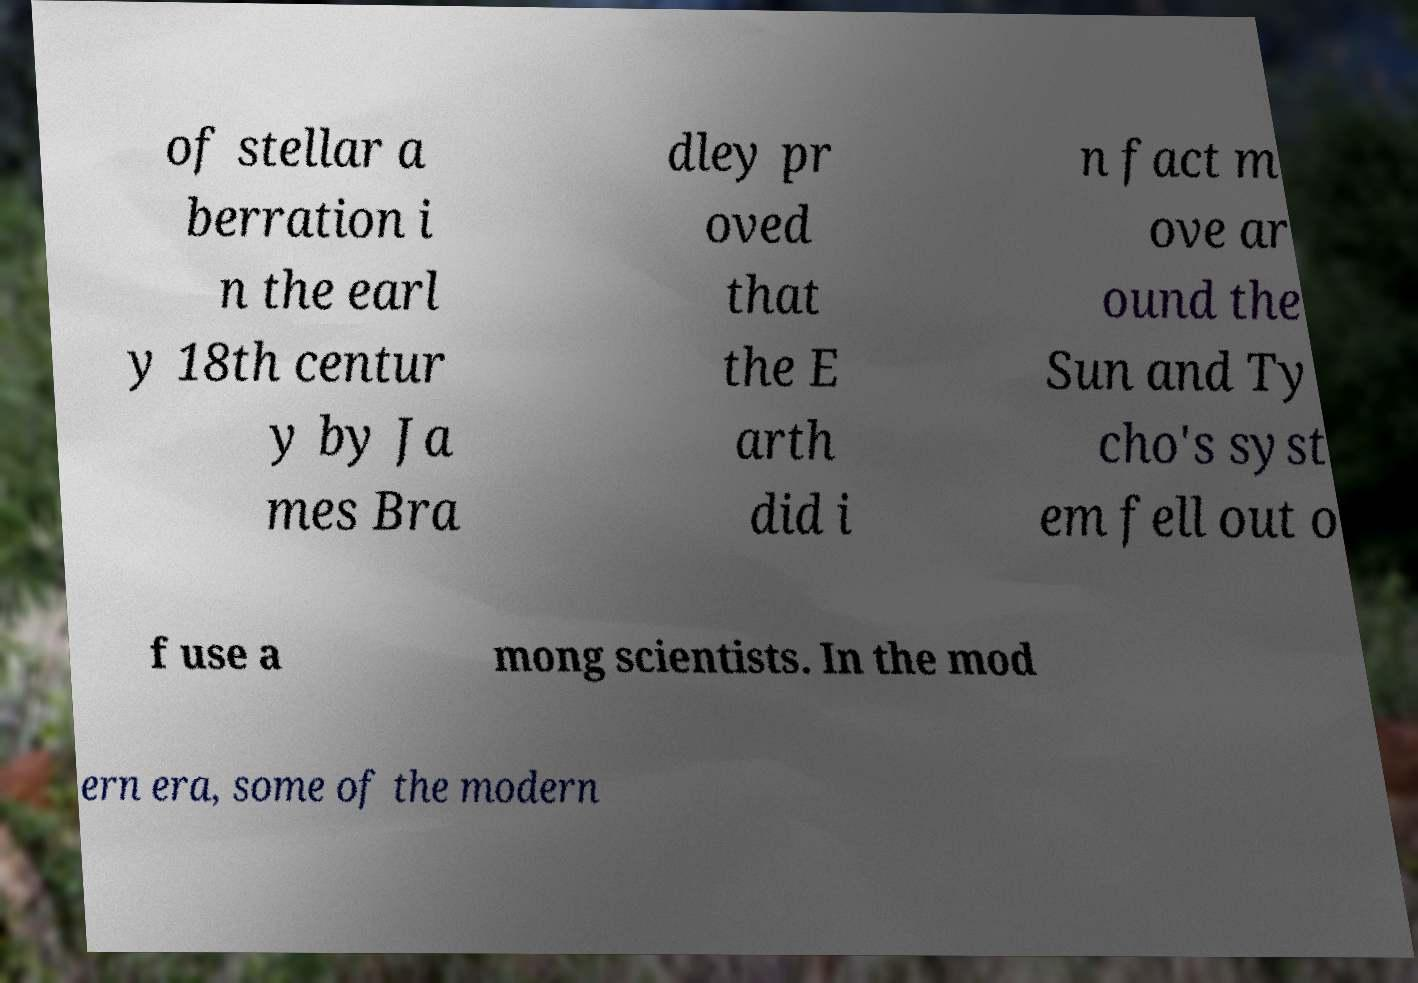Can you read and provide the text displayed in the image?This photo seems to have some interesting text. Can you extract and type it out for me? of stellar a berration i n the earl y 18th centur y by Ja mes Bra dley pr oved that the E arth did i n fact m ove ar ound the Sun and Ty cho's syst em fell out o f use a mong scientists. In the mod ern era, some of the modern 